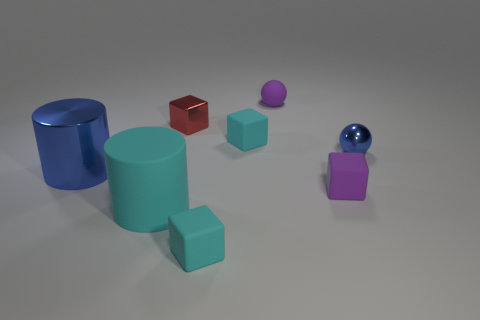Subtract all yellow blocks. Subtract all green cylinders. How many blocks are left? 4 Add 1 big cyan cylinders. How many objects exist? 9 Subtract all balls. How many objects are left? 6 Subtract all cyan blocks. Subtract all tiny shiny things. How many objects are left? 4 Add 3 big metal cylinders. How many big metal cylinders are left? 4 Add 1 blue spheres. How many blue spheres exist? 2 Subtract 0 green balls. How many objects are left? 8 